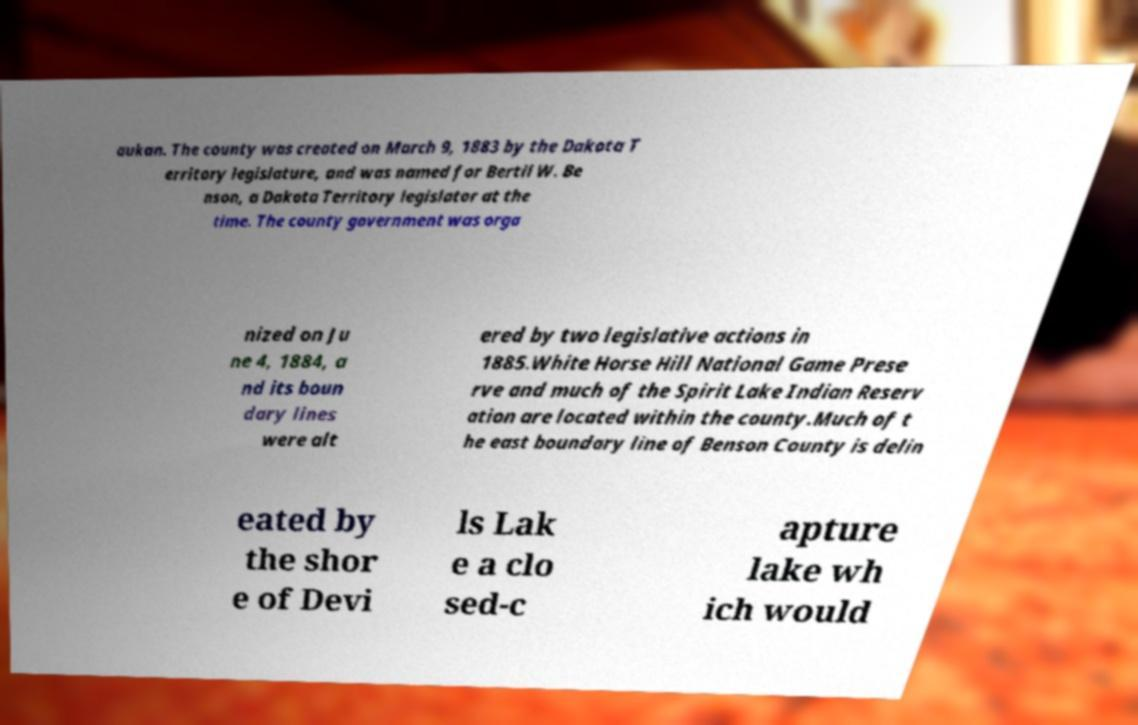I need the written content from this picture converted into text. Can you do that? aukan. The county was created on March 9, 1883 by the Dakota T erritory legislature, and was named for Bertil W. Be nson, a Dakota Territory legislator at the time. The county government was orga nized on Ju ne 4, 1884, a nd its boun dary lines were alt ered by two legislative actions in 1885.White Horse Hill National Game Prese rve and much of the Spirit Lake Indian Reserv ation are located within the county.Much of t he east boundary line of Benson County is delin eated by the shor e of Devi ls Lak e a clo sed-c apture lake wh ich would 